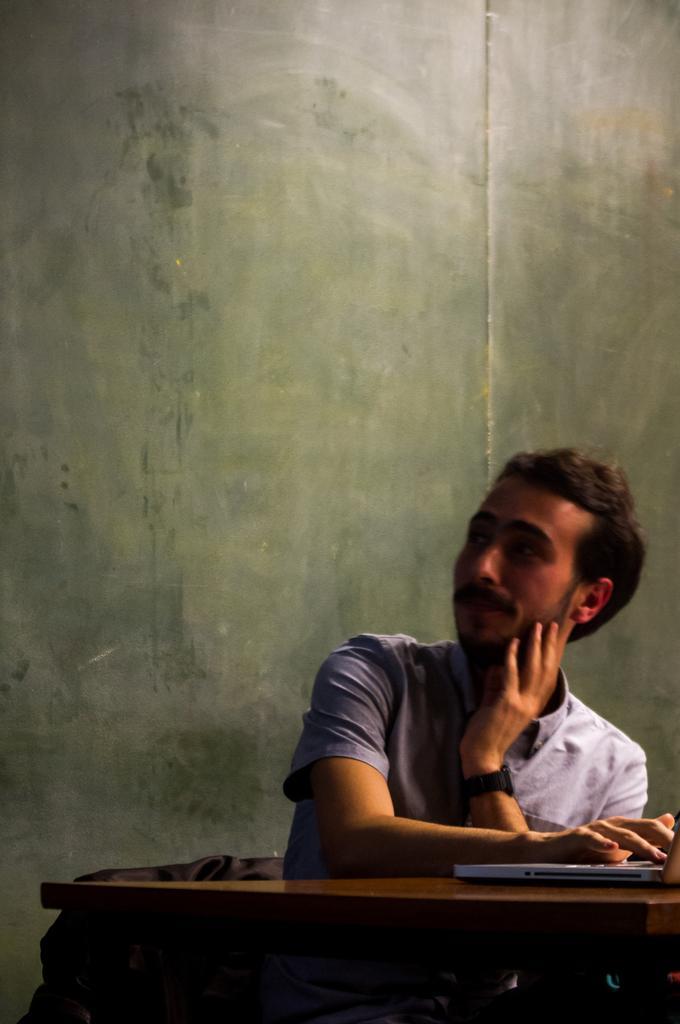In one or two sentences, can you explain what this image depicts? In the image we can see there is a person who is sitting on chair and on the table there is a laptop. 